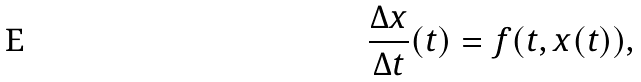<formula> <loc_0><loc_0><loc_500><loc_500>\frac { \Delta x } { \Delta t } ( t ) = f ( t , x ( t ) ) ,</formula> 